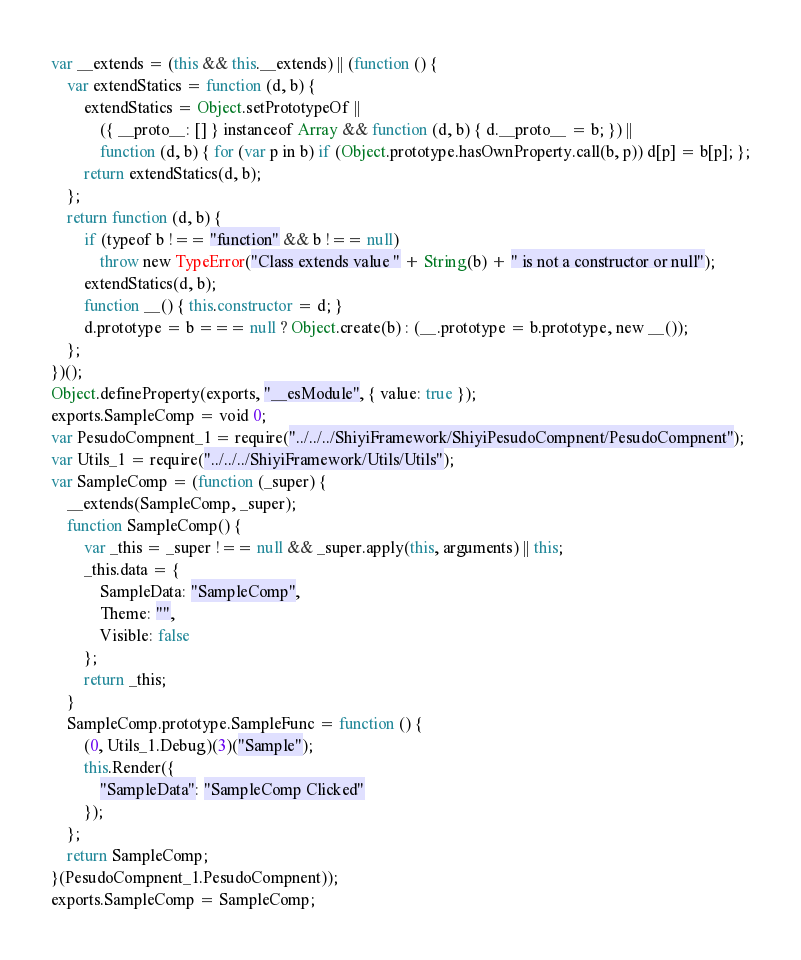<code> <loc_0><loc_0><loc_500><loc_500><_JavaScript_>var __extends = (this && this.__extends) || (function () {
    var extendStatics = function (d, b) {
        extendStatics = Object.setPrototypeOf ||
            ({ __proto__: [] } instanceof Array && function (d, b) { d.__proto__ = b; }) ||
            function (d, b) { for (var p in b) if (Object.prototype.hasOwnProperty.call(b, p)) d[p] = b[p]; };
        return extendStatics(d, b);
    };
    return function (d, b) {
        if (typeof b !== "function" && b !== null)
            throw new TypeError("Class extends value " + String(b) + " is not a constructor or null");
        extendStatics(d, b);
        function __() { this.constructor = d; }
        d.prototype = b === null ? Object.create(b) : (__.prototype = b.prototype, new __());
    };
})();
Object.defineProperty(exports, "__esModule", { value: true });
exports.SampleComp = void 0;
var PesudoCompnent_1 = require("../../../ShiyiFramework/ShiyiPesudoCompnent/PesudoCompnent");
var Utils_1 = require("../../../ShiyiFramework/Utils/Utils");
var SampleComp = (function (_super) {
    __extends(SampleComp, _super);
    function SampleComp() {
        var _this = _super !== null && _super.apply(this, arguments) || this;
        _this.data = {
            SampleData: "SampleComp",
            Theme: "",
            Visible: false
        };
        return _this;
    }
    SampleComp.prototype.SampleFunc = function () {
        (0, Utils_1.Debug)(3)("Sample");
        this.Render({
            "SampleData": "SampleComp Clicked"
        });
    };
    return SampleComp;
}(PesudoCompnent_1.PesudoCompnent));
exports.SampleComp = SampleComp;</code> 